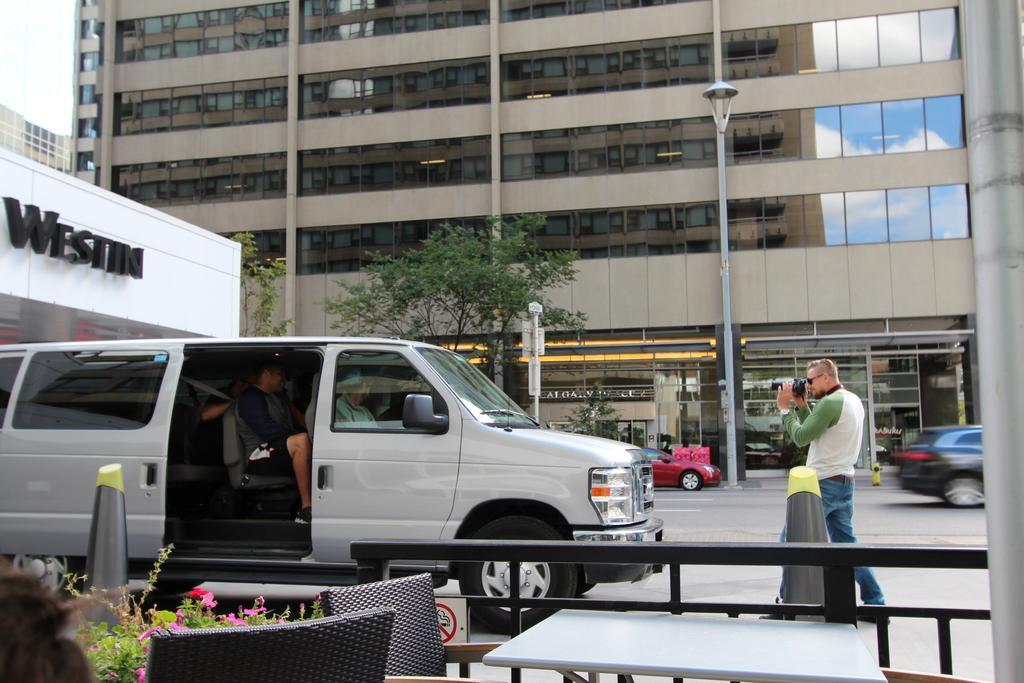Could you give a brief overview of what you see in this image? In this picture there is a car and inside there are people sitting and a man to the right side of the image is clicking the photo of them. In the background there are buildings and to the left side there is a building named weston. 